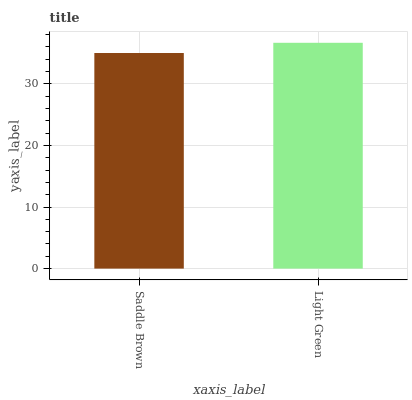Is Light Green the minimum?
Answer yes or no. No. Is Light Green greater than Saddle Brown?
Answer yes or no. Yes. Is Saddle Brown less than Light Green?
Answer yes or no. Yes. Is Saddle Brown greater than Light Green?
Answer yes or no. No. Is Light Green less than Saddle Brown?
Answer yes or no. No. Is Light Green the high median?
Answer yes or no. Yes. Is Saddle Brown the low median?
Answer yes or no. Yes. Is Saddle Brown the high median?
Answer yes or no. No. Is Light Green the low median?
Answer yes or no. No. 